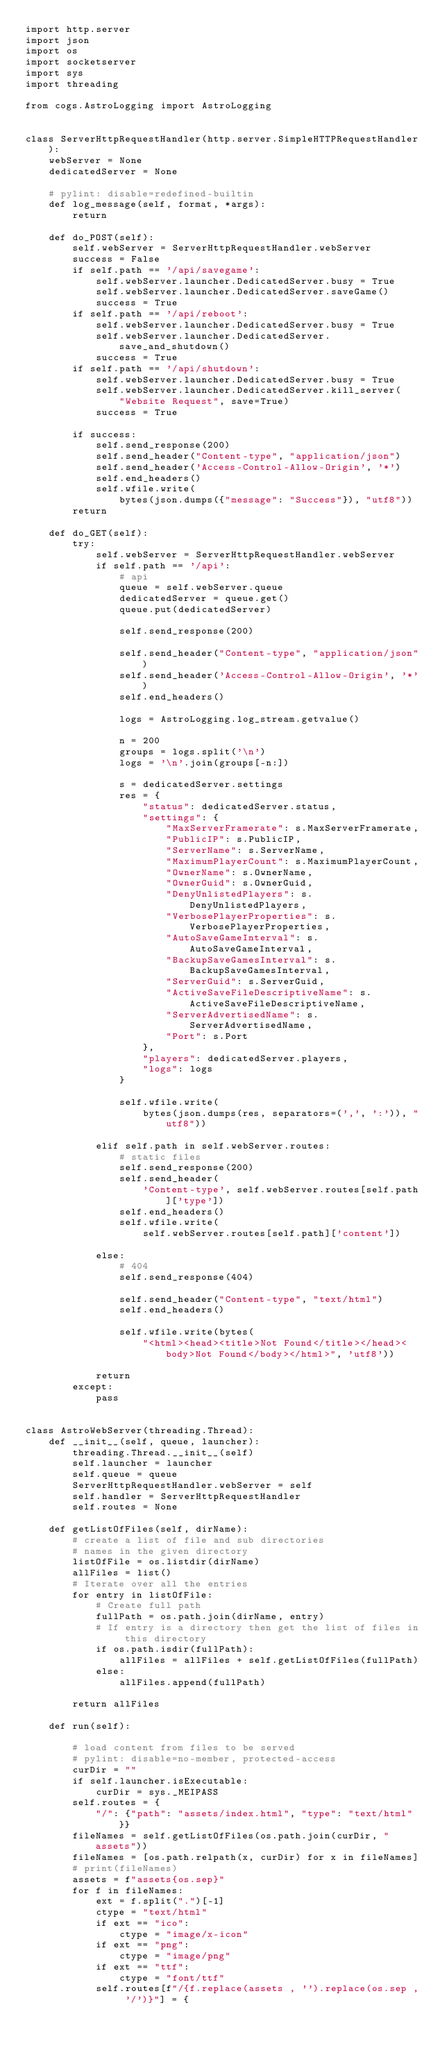<code> <loc_0><loc_0><loc_500><loc_500><_Python_>import http.server
import json
import os
import socketserver
import sys
import threading

from cogs.AstroLogging import AstroLogging


class ServerHttpRequestHandler(http.server.SimpleHTTPRequestHandler):
    webServer = None
    dedicatedServer = None

    # pylint: disable=redefined-builtin
    def log_message(self, format, *args):
        return

    def do_POST(self):
        self.webServer = ServerHttpRequestHandler.webServer
        success = False
        if self.path == '/api/savegame':
            self.webServer.launcher.DedicatedServer.busy = True
            self.webServer.launcher.DedicatedServer.saveGame()
            success = True
        if self.path == '/api/reboot':
            self.webServer.launcher.DedicatedServer.busy = True
            self.webServer.launcher.DedicatedServer.save_and_shutdown()
            success = True
        if self.path == '/api/shutdown':
            self.webServer.launcher.DedicatedServer.busy = True
            self.webServer.launcher.DedicatedServer.kill_server(
                "Website Request", save=True)
            success = True

        if success:
            self.send_response(200)
            self.send_header("Content-type", "application/json")
            self.send_header('Access-Control-Allow-Origin', '*')
            self.end_headers()
            self.wfile.write(
                bytes(json.dumps({"message": "Success"}), "utf8"))
        return

    def do_GET(self):
        try:
            self.webServer = ServerHttpRequestHandler.webServer
            if self.path == '/api':
                # api
                queue = self.webServer.queue
                dedicatedServer = queue.get()
                queue.put(dedicatedServer)

                self.send_response(200)

                self.send_header("Content-type", "application/json")
                self.send_header('Access-Control-Allow-Origin', '*')
                self.end_headers()

                logs = AstroLogging.log_stream.getvalue()

                n = 200
                groups = logs.split('\n')
                logs = '\n'.join(groups[-n:])

                s = dedicatedServer.settings
                res = {
                    "status": dedicatedServer.status,
                    "settings": {
                        "MaxServerFramerate": s.MaxServerFramerate,
                        "PublicIP": s.PublicIP,
                        "ServerName": s.ServerName,
                        "MaximumPlayerCount": s.MaximumPlayerCount,
                        "OwnerName": s.OwnerName,
                        "OwnerGuid": s.OwnerGuid,
                        "DenyUnlistedPlayers": s.DenyUnlistedPlayers,
                        "VerbosePlayerProperties": s.VerbosePlayerProperties,
                        "AutoSaveGameInterval": s.AutoSaveGameInterval,
                        "BackupSaveGamesInterval": s.BackupSaveGamesInterval,
                        "ServerGuid": s.ServerGuid,
                        "ActiveSaveFileDescriptiveName": s.ActiveSaveFileDescriptiveName,
                        "ServerAdvertisedName": s.ServerAdvertisedName,
                        "Port": s.Port
                    },
                    "players": dedicatedServer.players,
                    "logs": logs
                }

                self.wfile.write(
                    bytes(json.dumps(res, separators=(',', ':')), "utf8"))

            elif self.path in self.webServer.routes:
                # static files
                self.send_response(200)
                self.send_header(
                    'Content-type', self.webServer.routes[self.path]['type'])
                self.end_headers()
                self.wfile.write(
                    self.webServer.routes[self.path]['content'])

            else:
                # 404
                self.send_response(404)

                self.send_header("Content-type", "text/html")
                self.end_headers()

                self.wfile.write(bytes(
                    "<html><head><title>Not Found</title></head><body>Not Found</body></html>", 'utf8'))

            return
        except:
            pass


class AstroWebServer(threading.Thread):
    def __init__(self, queue, launcher):
        threading.Thread.__init__(self)
        self.launcher = launcher
        self.queue = queue
        ServerHttpRequestHandler.webServer = self
        self.handler = ServerHttpRequestHandler
        self.routes = None

    def getListOfFiles(self, dirName):
        # create a list of file and sub directories
        # names in the given directory
        listOfFile = os.listdir(dirName)
        allFiles = list()
        # Iterate over all the entries
        for entry in listOfFile:
            # Create full path
            fullPath = os.path.join(dirName, entry)
            # If entry is a directory then get the list of files in this directory
            if os.path.isdir(fullPath):
                allFiles = allFiles + self.getListOfFiles(fullPath)
            else:
                allFiles.append(fullPath)

        return allFiles

    def run(self):

        # load content from files to be served
        # pylint: disable=no-member, protected-access
        curDir = ""
        if self.launcher.isExecutable:
            curDir = sys._MEIPASS
        self.routes = {
            "/": {"path": "assets/index.html", "type": "text/html"}}
        fileNames = self.getListOfFiles(os.path.join(curDir, "assets"))
        fileNames = [os.path.relpath(x, curDir) for x in fileNames]
        # print(fileNames)
        assets = f"assets{os.sep}"
        for f in fileNames:
            ext = f.split(".")[-1]
            ctype = "text/html"
            if ext == "ico":
                ctype = "image/x-icon"
            if ext == "png":
                ctype = "image/png"
            if ext == "ttf":
                ctype = "font/ttf"
            self.routes[f"/{f.replace(assets , '').replace(os.sep , '/')}"] = {</code> 